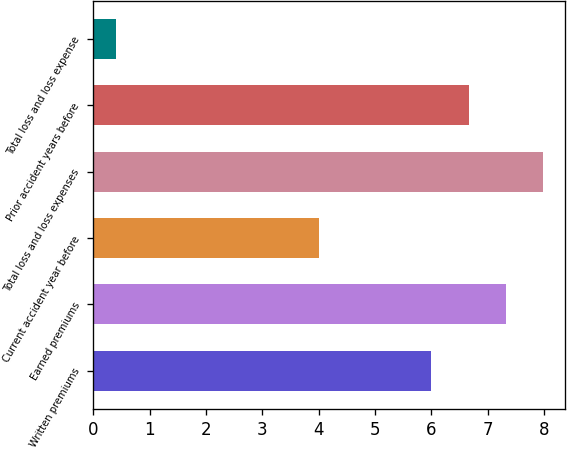<chart> <loc_0><loc_0><loc_500><loc_500><bar_chart><fcel>Written premiums<fcel>Earned premiums<fcel>Current accident year before<fcel>Total loss and loss expenses<fcel>Prior accident years before<fcel>Total loss and loss expense<nl><fcel>6<fcel>7.32<fcel>4<fcel>7.98<fcel>6.66<fcel>0.4<nl></chart> 